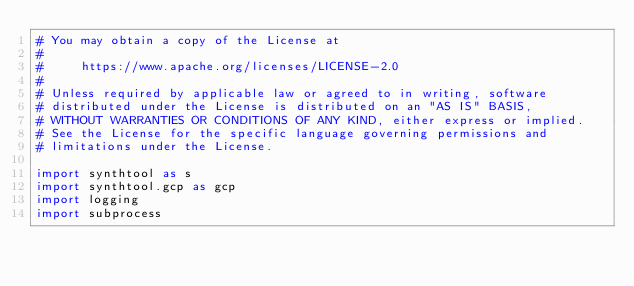<code> <loc_0><loc_0><loc_500><loc_500><_Python_># You may obtain a copy of the License at
#
#     https://www.apache.org/licenses/LICENSE-2.0
#
# Unless required by applicable law or agreed to in writing, software
# distributed under the License is distributed on an "AS IS" BASIS,
# WITHOUT WARRANTIES OR CONDITIONS OF ANY KIND, either express or implied.
# See the License for the specific language governing permissions and
# limitations under the License.

import synthtool as s
import synthtool.gcp as gcp
import logging
import subprocess
</code> 